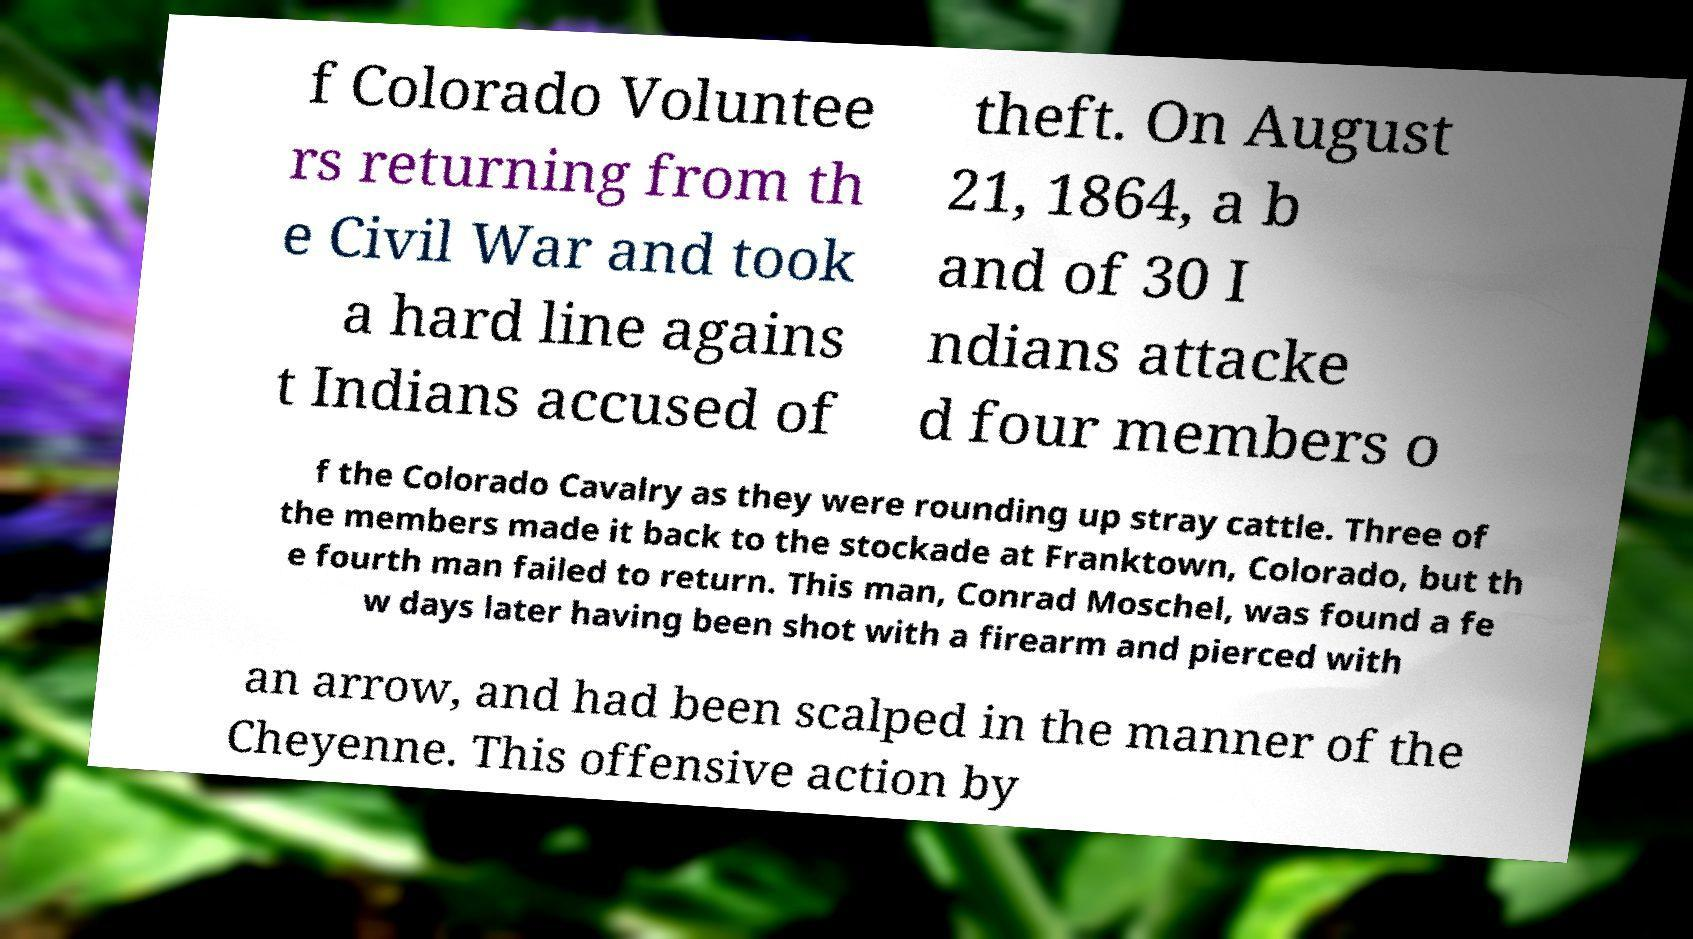Could you extract and type out the text from this image? f Colorado Voluntee rs returning from th e Civil War and took a hard line agains t Indians accused of theft. On August 21, 1864, a b and of 30 I ndians attacke d four members o f the Colorado Cavalry as they were rounding up stray cattle. Three of the members made it back to the stockade at Franktown, Colorado, but th e fourth man failed to return. This man, Conrad Moschel, was found a fe w days later having been shot with a firearm and pierced with an arrow, and had been scalped in the manner of the Cheyenne. This offensive action by 